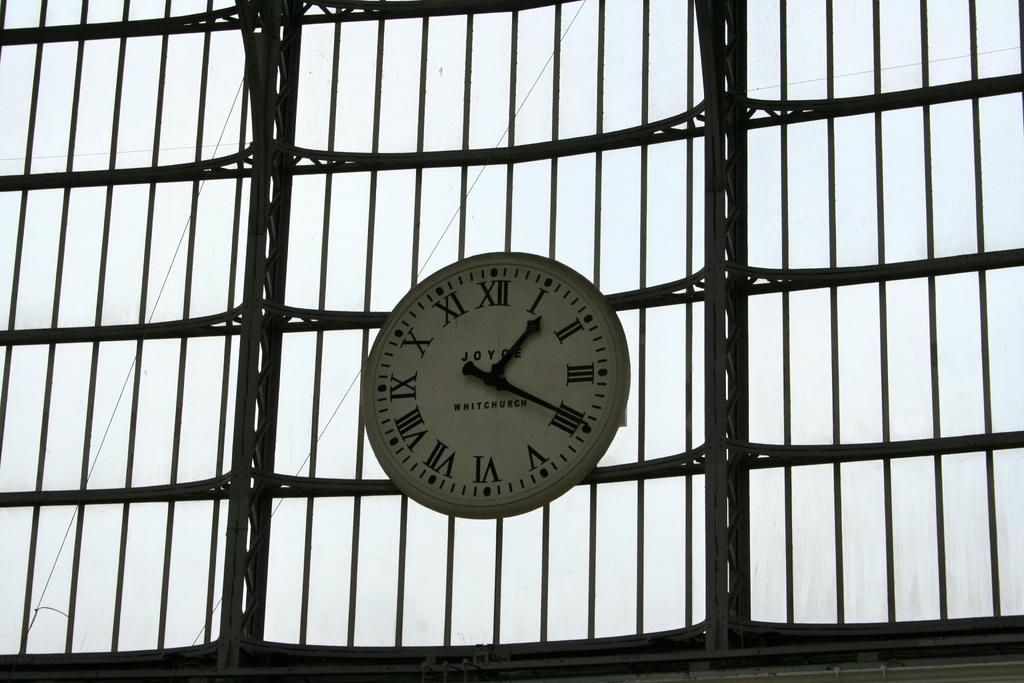<image>
Offer a succinct explanation of the picture presented. a clock with many roman numerals on it 